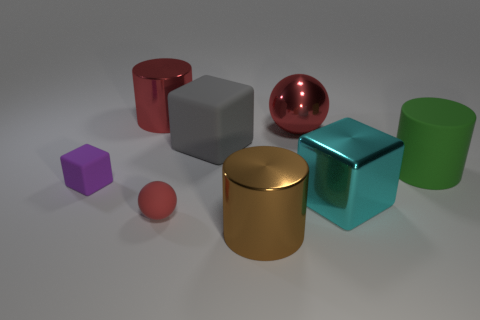Subtract all large metallic blocks. How many blocks are left? 2 Add 2 gray rubber balls. How many objects exist? 10 Subtract 1 cylinders. How many cylinders are left? 2 Subtract all blocks. How many objects are left? 5 Subtract 1 green cylinders. How many objects are left? 7 Subtract all big rubber cylinders. Subtract all small cyan metal objects. How many objects are left? 7 Add 4 gray matte cubes. How many gray matte cubes are left? 5 Add 7 balls. How many balls exist? 9 